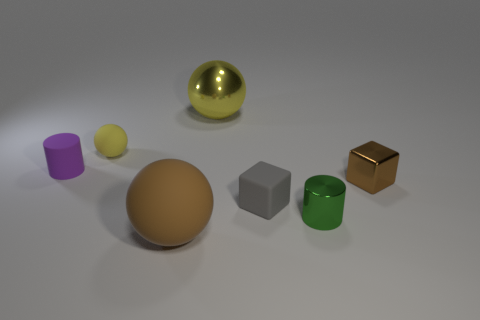Subtract all large brown matte balls. How many balls are left? 2 Subtract all yellow spheres. How many spheres are left? 1 Subtract 1 cylinders. How many cylinders are left? 1 Subtract all cyan cylinders. Subtract all cyan balls. How many cylinders are left? 2 Subtract all green spheres. How many yellow blocks are left? 0 Subtract all large brown matte spheres. Subtract all large things. How many objects are left? 4 Add 1 tiny green shiny cylinders. How many tiny green shiny cylinders are left? 2 Add 1 yellow spheres. How many yellow spheres exist? 3 Add 1 tiny purple things. How many objects exist? 8 Subtract 0 cyan blocks. How many objects are left? 7 